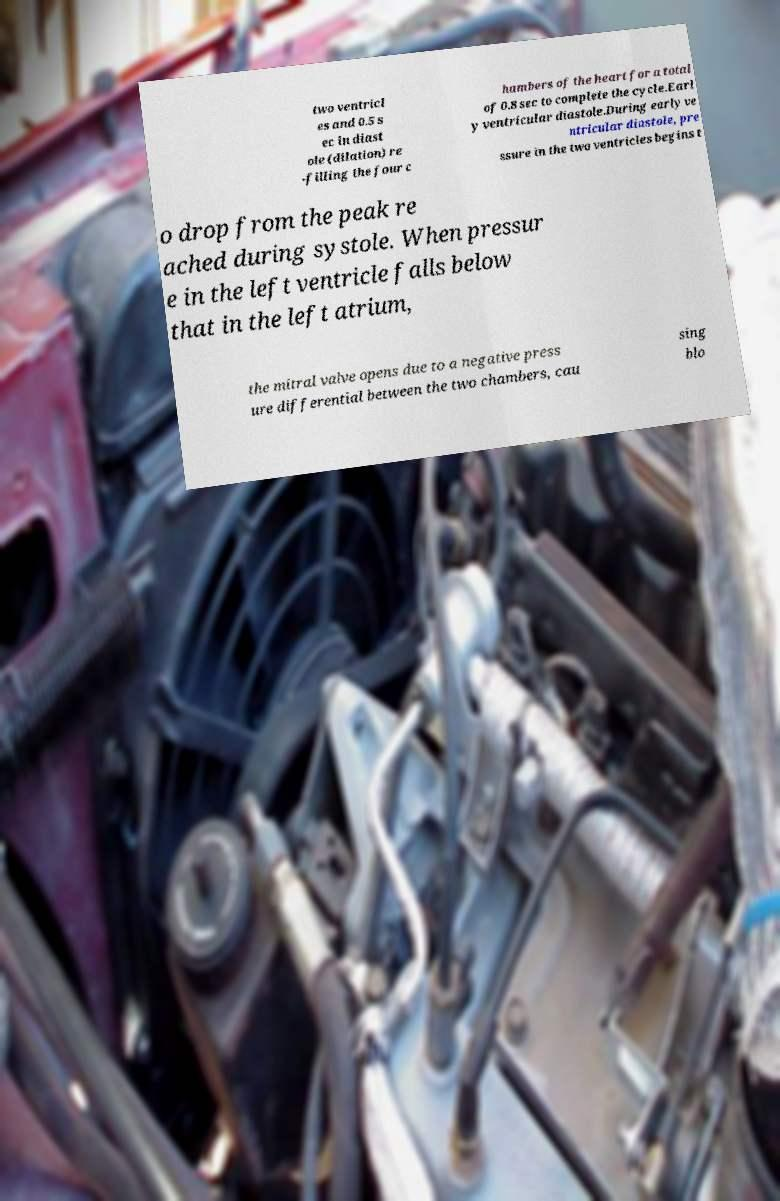I need the written content from this picture converted into text. Can you do that? two ventricl es and 0.5 s ec in diast ole (dilation) re -filling the four c hambers of the heart for a total of 0.8 sec to complete the cycle.Earl y ventricular diastole.During early ve ntricular diastole, pre ssure in the two ventricles begins t o drop from the peak re ached during systole. When pressur e in the left ventricle falls below that in the left atrium, the mitral valve opens due to a negative press ure differential between the two chambers, cau sing blo 